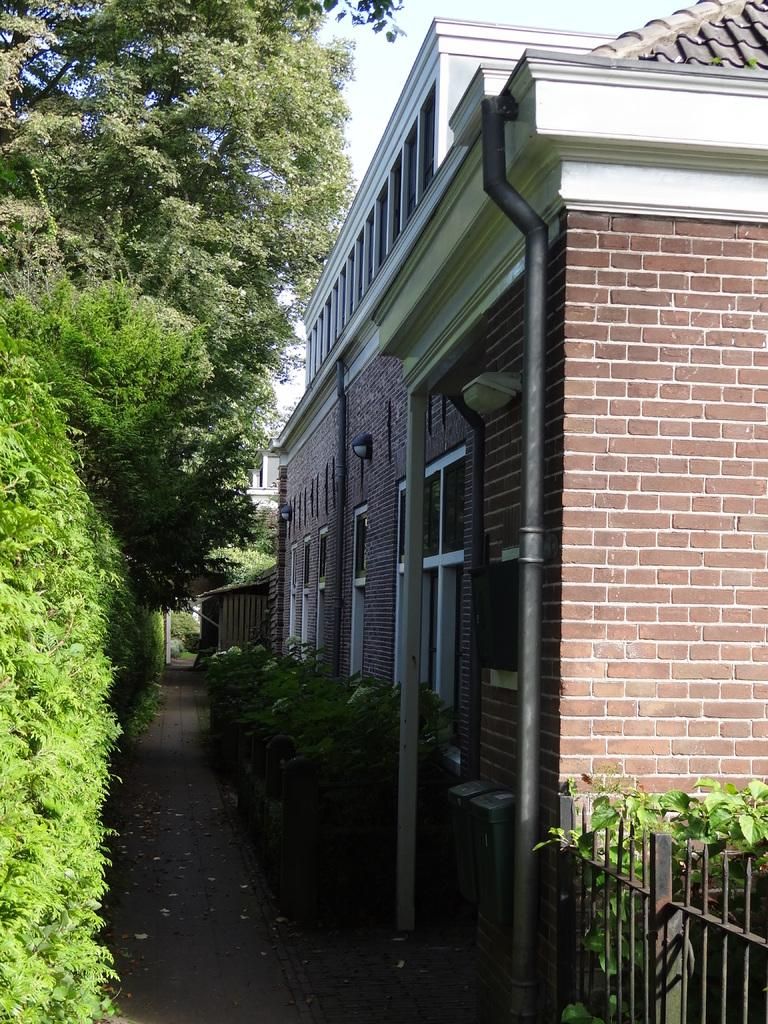What is located in the center of the image? In the center of the image, there are trees, plants, grass, poles, windows, a building, a roof, a wall, and a fence. Can you describe the natural elements in the center of the image? The natural elements in the center of the image include trees, plants, and grass. What type of structure is present in the center of the image? There is a building in the center of the image. What architectural features can be seen in the center of the image? In the center of the image, there are poles, windows, a roof, a wall, and a fence. What is visible in the background of the image? In the background of the image, the sky, clouds, and possibly more of the building can be seen. What type of mark can be seen on the downtown place in the image? There is no downtown place mentioned in the facts, and no mark is visible in the image. 